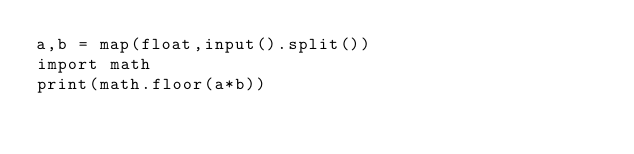<code> <loc_0><loc_0><loc_500><loc_500><_Python_>a,b = map(float,input().split())
import math
print(math.floor(a*b))</code> 